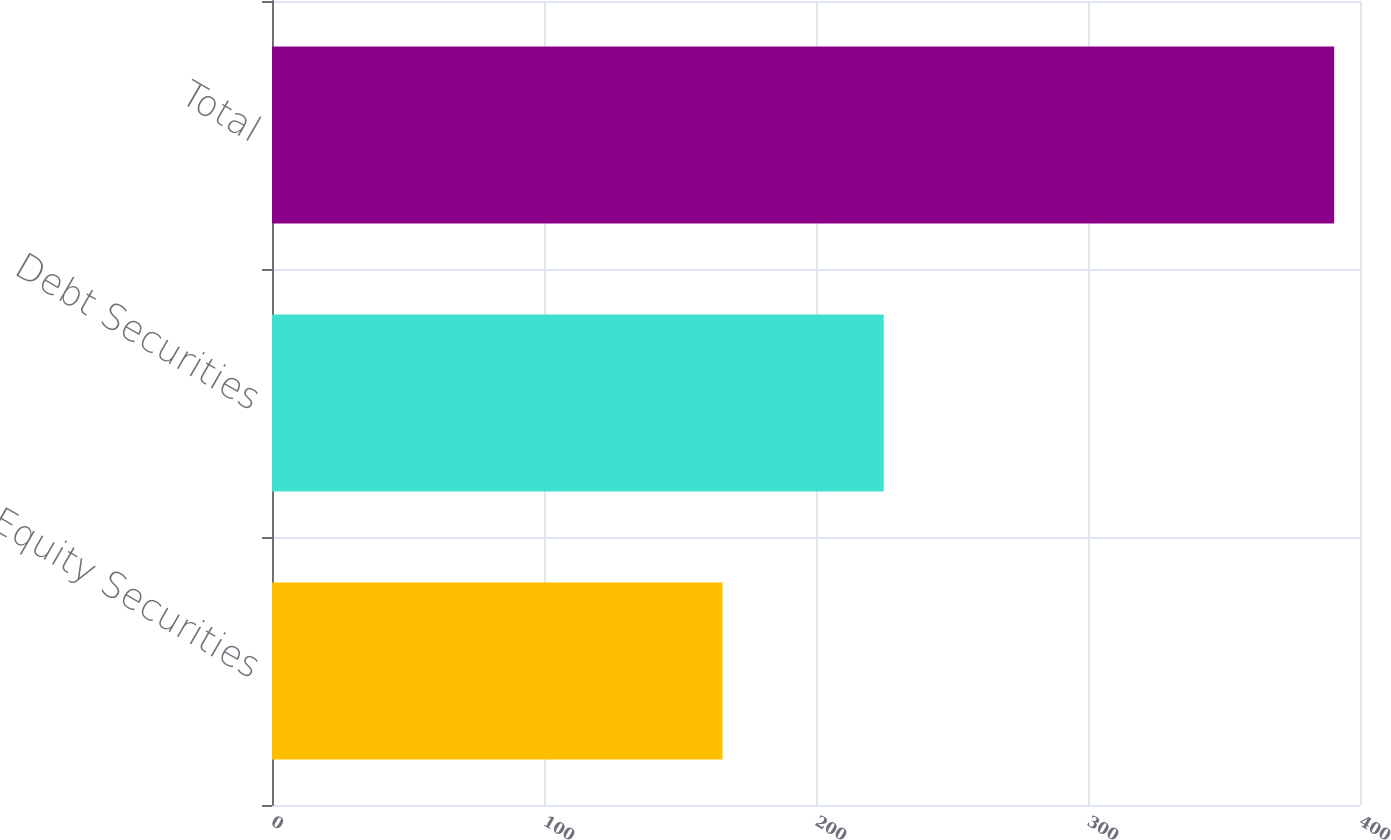Convert chart. <chart><loc_0><loc_0><loc_500><loc_500><bar_chart><fcel>Equity Securities<fcel>Debt Securities<fcel>Total<nl><fcel>165.6<fcel>224.9<fcel>390.5<nl></chart> 